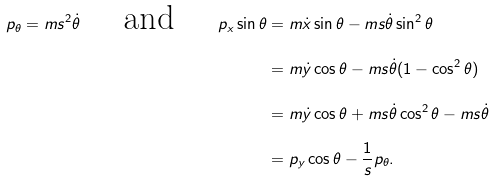<formula> <loc_0><loc_0><loc_500><loc_500>p _ { \theta } = m s ^ { 2 } \dot { \theta } \quad \text { and } \quad p _ { x } \sin \theta & = m \dot { x } \sin \theta - m s \dot { \theta } \sin ^ { 2 } \theta \\ & = m \dot { y } \cos \theta - m s \dot { \theta } ( 1 - \cos ^ { 2 } \theta ) \\ & = m \dot { y } \cos \theta + m s \dot { \theta } \cos ^ { 2 } \theta - m s \dot { \theta } \\ & = p _ { y } \cos \theta - \frac { 1 } { s } p _ { \theta } .</formula> 